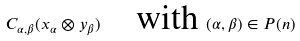<formula> <loc_0><loc_0><loc_500><loc_500>C _ { \alpha , \beta } ( x _ { \alpha } \otimes y _ { \beta } ) \quad \text {with } ( \alpha , \beta ) \in P ( n )</formula> 